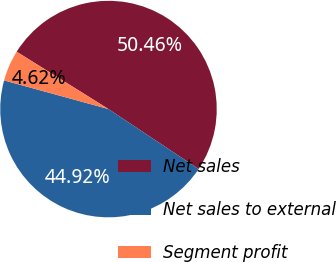Convert chart. <chart><loc_0><loc_0><loc_500><loc_500><pie_chart><fcel>Net sales<fcel>Net sales to external<fcel>Segment profit<nl><fcel>50.46%<fcel>44.92%<fcel>4.62%<nl></chart> 